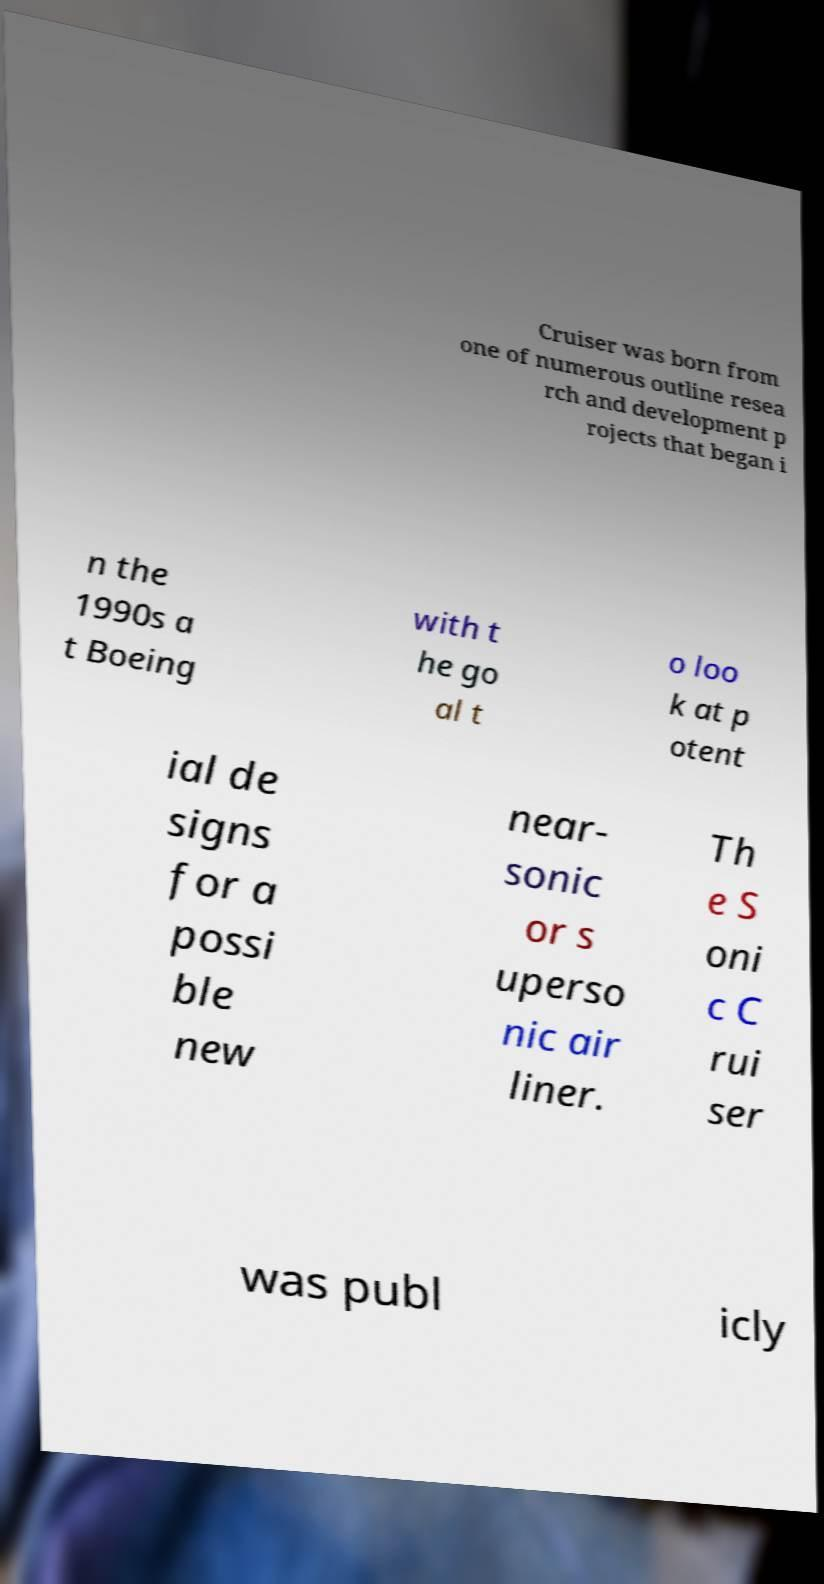There's text embedded in this image that I need extracted. Can you transcribe it verbatim? Cruiser was born from one of numerous outline resea rch and development p rojects that began i n the 1990s a t Boeing with t he go al t o loo k at p otent ial de signs for a possi ble new near- sonic or s uperso nic air liner. Th e S oni c C rui ser was publ icly 